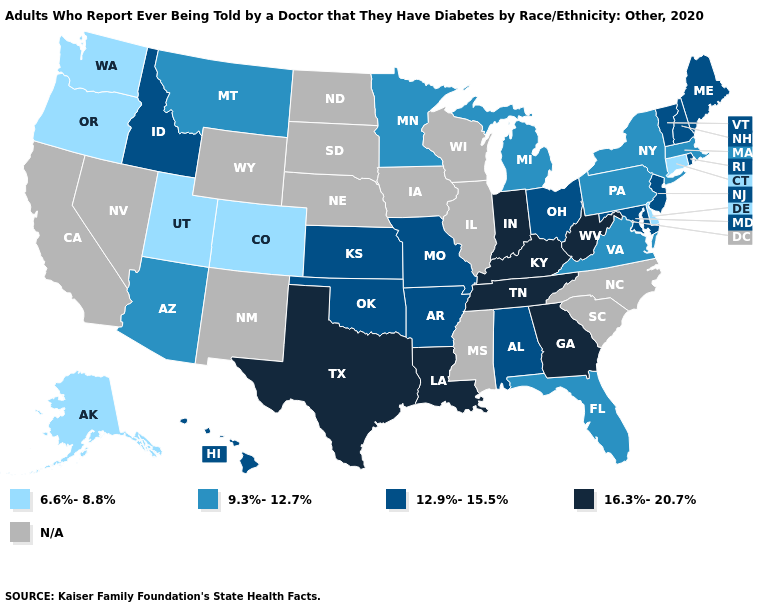What is the lowest value in states that border Pennsylvania?
Give a very brief answer. 6.6%-8.8%. Does Rhode Island have the lowest value in the Northeast?
Write a very short answer. No. What is the value of Alabama?
Keep it brief. 12.9%-15.5%. Does Oregon have the lowest value in the USA?
Quick response, please. Yes. Name the states that have a value in the range 9.3%-12.7%?
Concise answer only. Arizona, Florida, Massachusetts, Michigan, Minnesota, Montana, New York, Pennsylvania, Virginia. Name the states that have a value in the range 12.9%-15.5%?
Write a very short answer. Alabama, Arkansas, Hawaii, Idaho, Kansas, Maine, Maryland, Missouri, New Hampshire, New Jersey, Ohio, Oklahoma, Rhode Island, Vermont. Which states have the highest value in the USA?
Write a very short answer. Georgia, Indiana, Kentucky, Louisiana, Tennessee, Texas, West Virginia. Does Idaho have the highest value in the West?
Concise answer only. Yes. Name the states that have a value in the range N/A?
Write a very short answer. California, Illinois, Iowa, Mississippi, Nebraska, Nevada, New Mexico, North Carolina, North Dakota, South Carolina, South Dakota, Wisconsin, Wyoming. Which states hav the highest value in the West?
Quick response, please. Hawaii, Idaho. What is the value of Illinois?
Answer briefly. N/A. Which states have the lowest value in the MidWest?
Be succinct. Michigan, Minnesota. 